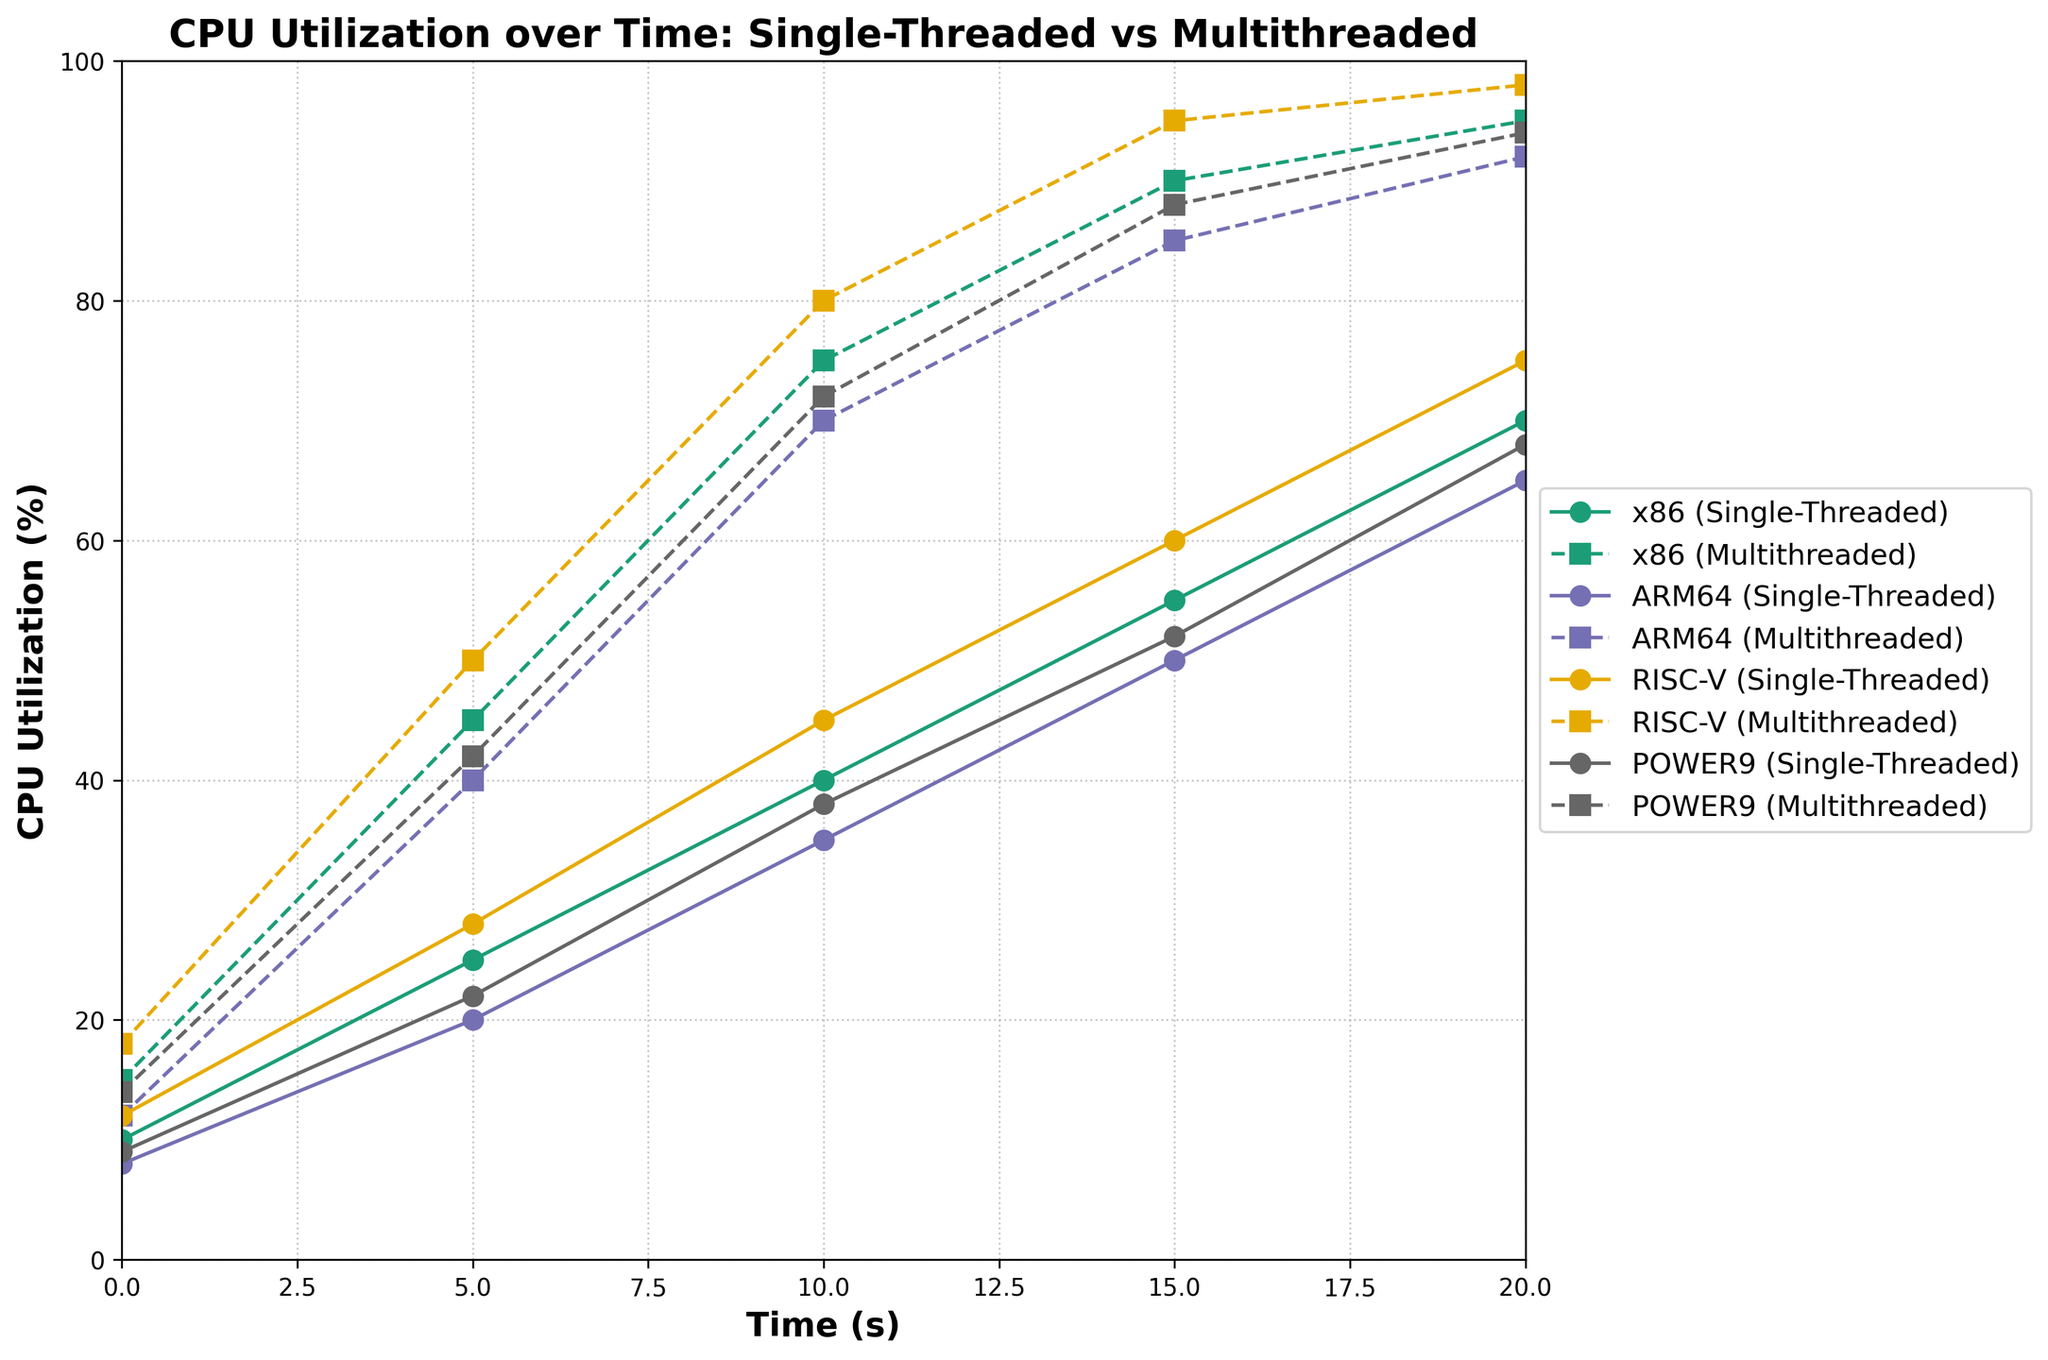Which architecture has the highest multithreaded CPU utilization at 20 seconds? To find the highest multithreaded CPU utilization at 20 seconds, compare the multi-threaded utilization values for each architecture at the 20-second mark. From the figure, we can see that RISC-V has the highest value at 98%.
Answer: RISC-V Which architecture shows the largest difference in CPU utilization between single-threaded and multithreaded processing at 10 seconds? To find the largest difference in CPU utilization at 10 seconds, calculate the difference between multithreaded and single-threaded CPU utilization for each architecture at this time point: x86 (75-40=35), ARM64 (70-35=35), RISC-V (80-45=35), and POWER9 (72-38=34). The highest difference is for x86, ARM64, and RISC-V with 35%.
Answer: x86, ARM64, RISC-V By how much does the multithreaded CPU utilization for ARM64 increase between 5 and 15 seconds? To determine the increase in multithreaded CPU utilization for ARM64, subtract the value at 5 seconds from the value at 15 seconds: 85% (at 15s) - 40% (at 5s) = 45%. This means the CPU utilization increases by 45%.
Answer: 45% At which time point does single-threaded CPU utilization surpass 50% for x86 and reach its peak value for ARM64? To find this, observe the curves for x86 and ARM64 single-threaded utilization. For x86, single-threaded utilization surpasses 50% at 15 seconds. For ARM64, it reaches its peak value of 65% at 20 seconds.
Answer: 15 seconds (x86), 20 seconds (ARM64) What is the median of the single-threaded CPU utilization for POWER9 at all provided time points? The single-threaded CPU utilization values for POWER9 at all time points are 9%, 22%, 38%, 52%, and 68%. To find the median, arrange these numbers in ascending order and select the middle value: 9, 22, 38, 52, 68. The median value is 38%.
Answer: 38% Which architecture has the smallest difference in multithreaded CPU utilization between 10 and 20 seconds? To determine this, subtract the 10-second values from the 20-second values for each architecture's multithreaded utilization: x86 (95-75=20), ARM64 (92-70=22), RISC-V (98-80=18), and POWER9 (94-72=22). The smallest difference is for RISC-V with 18%.
Answer: RISC-V Compare the single-threaded CPU utilization of x86 at 10 seconds with the multithreaded CPU utilization of ARM64 at 5 seconds. Which is higher? To compare, look at x86 single-threaded utilization at 10 seconds (40%) and ARM64 multithreaded utilization at 5 seconds (40%). Both values are equal at 40%.
Answer: Equal (40%) 